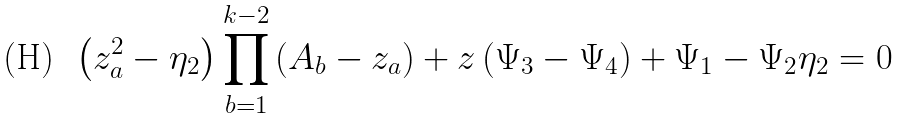Convert formula to latex. <formula><loc_0><loc_0><loc_500><loc_500>\left ( z _ { a } ^ { 2 } - \eta _ { 2 } \right ) \prod _ { b = 1 } ^ { k - 2 } \left ( A _ { b } - z _ { a } \right ) + z \left ( \Psi _ { 3 } - \Psi _ { 4 } \right ) + \Psi _ { 1 } - \Psi _ { 2 } \eta _ { 2 } = 0</formula> 